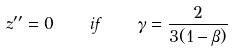<formula> <loc_0><loc_0><loc_500><loc_500>z ^ { \prime \prime } = 0 \quad i f \quad \gamma = \frac { 2 } { 3 ( 1 - \beta ) }</formula> 